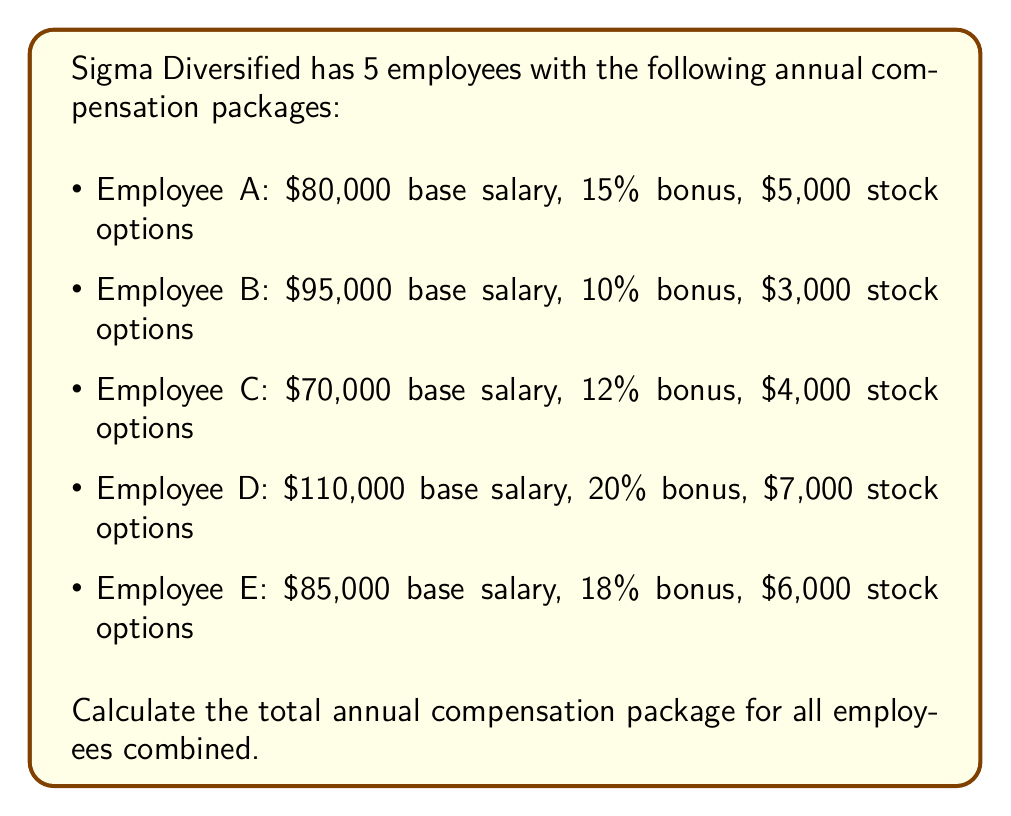Show me your answer to this math problem. To calculate the total compensation package, we need to sum up the base salary, bonus, and stock options for each employee:

1. Employee A:
   Base salary: $80,000
   Bonus: $80,000 * 0.15 = $12,000
   Stock options: $5,000
   Total: $80,000 + $12,000 + $5,000 = $97,000

2. Employee B:
   Base salary: $95,000
   Bonus: $95,000 * 0.10 = $9,500
   Stock options: $3,000
   Total: $95,000 + $9,500 + $3,000 = $107,500

3. Employee C:
   Base salary: $70,000
   Bonus: $70,000 * 0.12 = $8,400
   Stock options: $4,000
   Total: $70,000 + $8,400 + $4,000 = $82,400

4. Employee D:
   Base salary: $110,000
   Bonus: $110,000 * 0.20 = $22,000
   Stock options: $7,000
   Total: $110,000 + $22,000 + $7,000 = $139,000

5. Employee E:
   Base salary: $85,000
   Bonus: $85,000 * 0.18 = $15,300
   Stock options: $6,000
   Total: $85,000 + $15,300 + $6,000 = $106,300

Now, we sum up the total compensation for all employees:

$$ \text{Total} = 97,000 + 107,500 + 82,400 + 139,000 + 106,300 = 532,200 $$
Answer: $532,200 